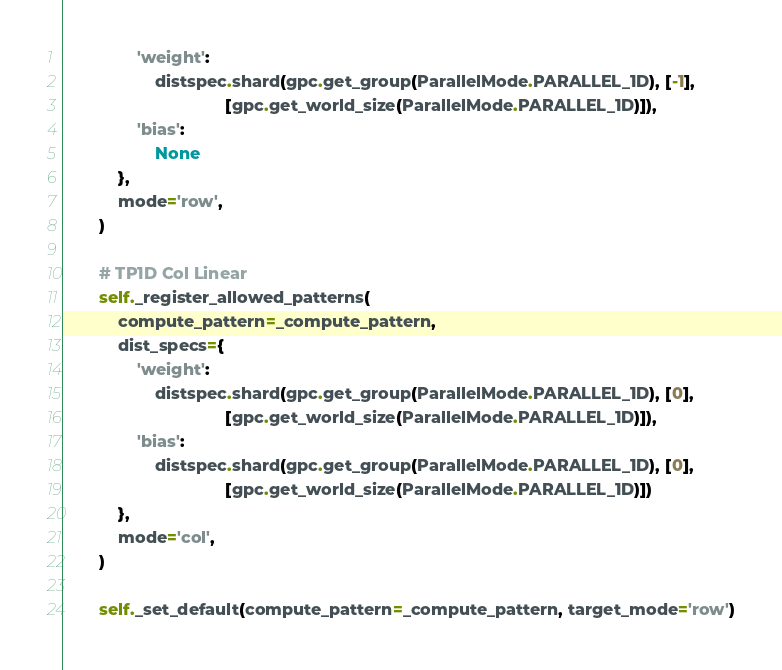Convert code to text. <code><loc_0><loc_0><loc_500><loc_500><_Python_>                'weight':
                    distspec.shard(gpc.get_group(ParallelMode.PARALLEL_1D), [-1],
                                   [gpc.get_world_size(ParallelMode.PARALLEL_1D)]),
                'bias':
                    None
            },
            mode='row',
        )

        # TP1D Col Linear
        self._register_allowed_patterns(
            compute_pattern=_compute_pattern,
            dist_specs={
                'weight':
                    distspec.shard(gpc.get_group(ParallelMode.PARALLEL_1D), [0],
                                   [gpc.get_world_size(ParallelMode.PARALLEL_1D)]),
                'bias':
                    distspec.shard(gpc.get_group(ParallelMode.PARALLEL_1D), [0],
                                   [gpc.get_world_size(ParallelMode.PARALLEL_1D)])
            },
            mode='col',
        )

        self._set_default(compute_pattern=_compute_pattern, target_mode='row')
</code> 